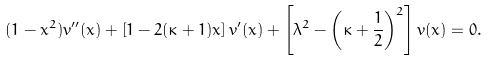Convert formula to latex. <formula><loc_0><loc_0><loc_500><loc_500>( 1 - x ^ { 2 } ) v ^ { \prime \prime } ( x ) + \left [ 1 - 2 ( \kappa + 1 ) x \right ] v ^ { \prime } ( x ) + \left [ \lambda ^ { 2 } - \left ( \kappa + \frac { 1 } { 2 } \right ) ^ { 2 } \right ] v ( x ) = 0 .</formula> 